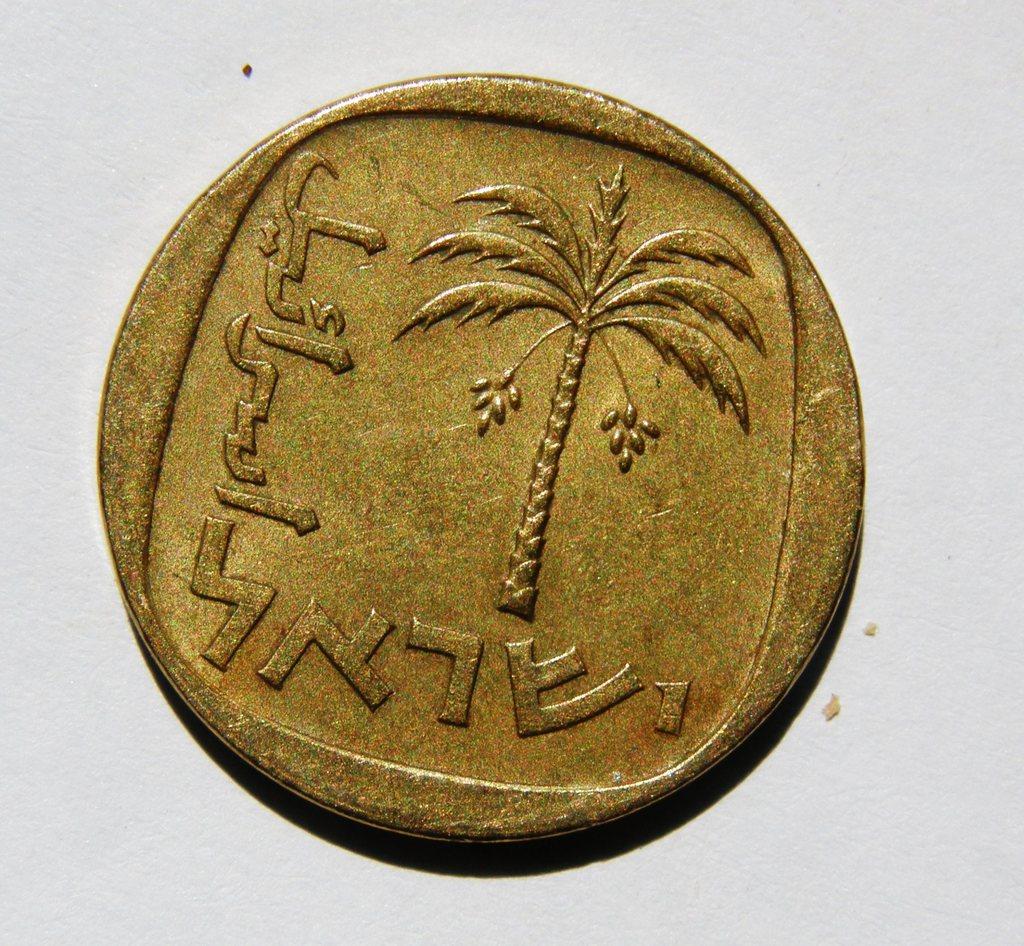Is the language on the coin english?
Make the answer very short. No. 